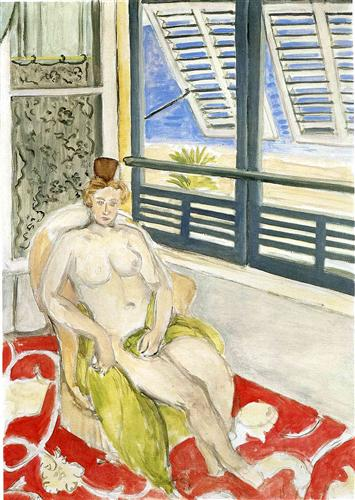What mood does the artist seem to convey through this painting? The artist conveys a mood of serene contemplation through the use of soft, harmonious colors and the relaxed pose of the woman. The open window introduces elements of the natural world, suggesting a connection to something beyond the immediate surroundings. This adds a layer of peacefulness and suggests a contemplative escape from the hustle of everyday life. 